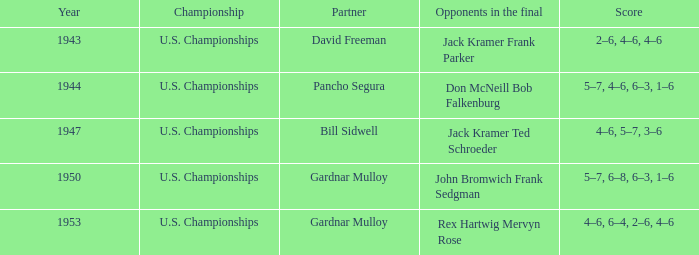Which Score has Opponents in the final of john bromwich frank sedgman? 5–7, 6–8, 6–3, 1–6. 